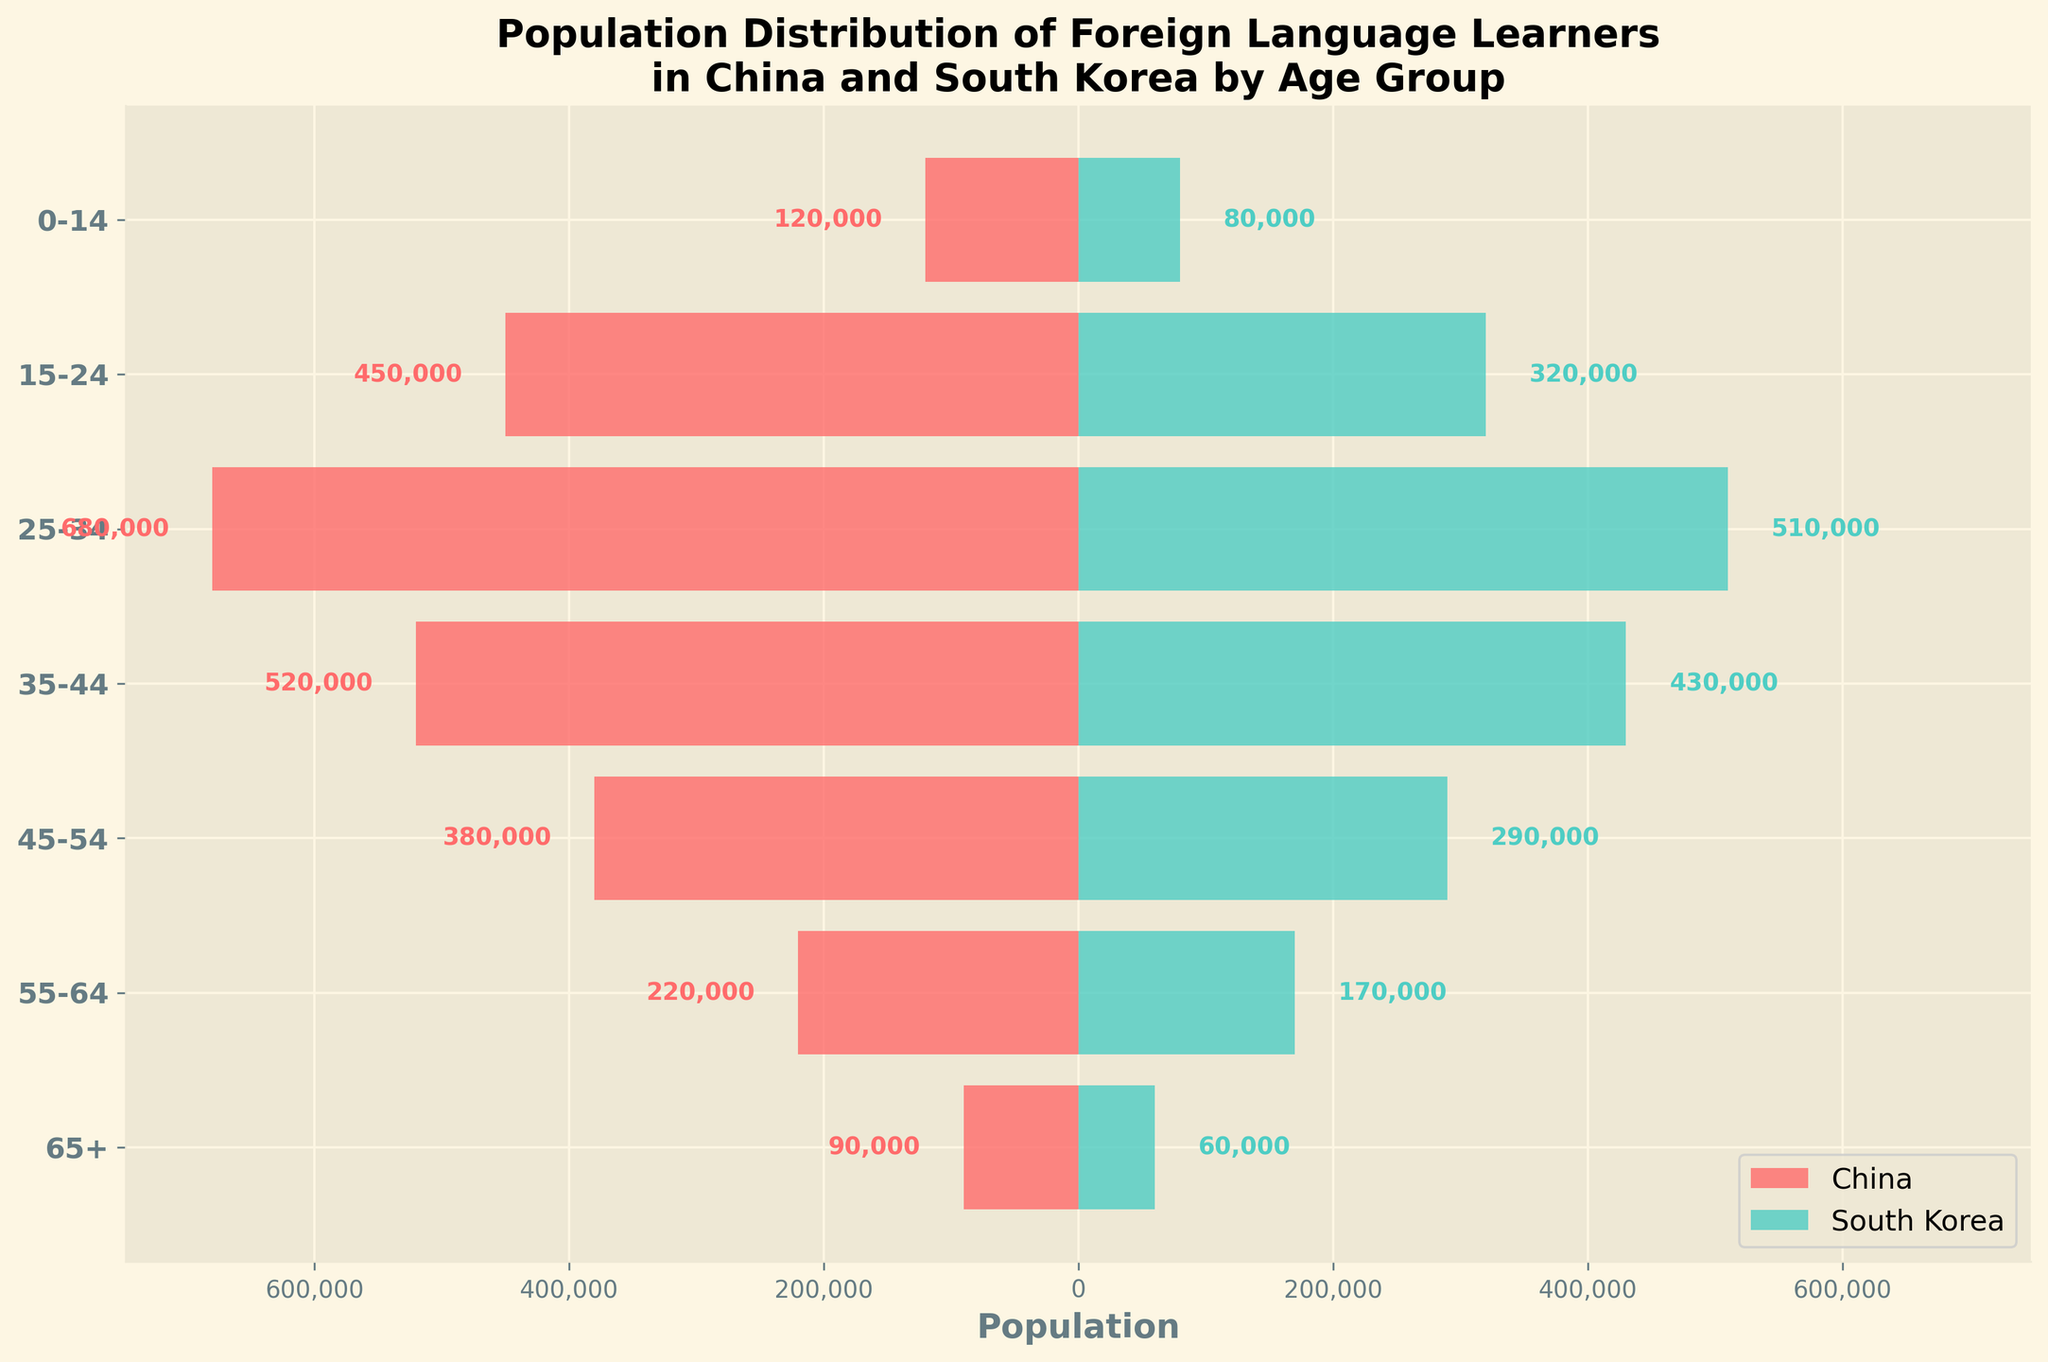Which country has a higher number of foreign language learners in the 25-34 age group? Compare the bars for China and South Korea corresponding to the 25-34 age group. China has 680,000 learners, while South Korea has 510,000.
Answer: China What is the total number of foreign language learners aged 0-14 in both countries? Sum the values for China and South Korea in the 0-14 age group. China: 120,000, South Korea: 80,000. So, 120,000 + 80,000 = 200,000.
Answer: 200,000 Which age group has the highest number of foreign language learners in China? Identify the longest bar for China. The age group 25-34 has the highest number with 680,000 learners.
Answer: 25-34 What is the difference in the number of foreign language learners in the 45-54 age group between China and South Korea? Find the values for China and South Korea in the 45-54 age group and subtract: 380,000 (China) - 290,000 (South Korea) = 90,000.
Answer: 90,000 How does the number of foreign language learners aged 55-64 in South Korea compare to those aged 65+ in China? Compare the bar lengths for the 55-64 age group in South Korea (170,000) and the 65+ age group in China (90,000). 170,000 (South Korea) is greater than 90,000 (China).
Answer: Greater What is the average number of foreign language learners across all age groups in China? Add the numbers for all age groups in China and divide by the number of age groups. (120,000 + 450,000 + 680,000 + 520,000 + 380,000 + 220,000 + 90,000) / 7 = 350,000.
Answer: 350,000 Is there any age group where the number of foreign language learners is equal in China and South Korea? Visually compare the bars for both countries in each age group. All bars are of different lengths in every age group, indicating no equal numbers.
Answer: No Which country has a higher number of foreign language learners overall? Sum the values for all age groups in each country and compare. China: (120,000 + 450,000 + 680,000 + 520,000 + 380,000 + 220,000 + 90,000) = 2,460,000, South Korea: (80,000 + 320,000 + 510,000 + 430,000 + 290,000 + 170,000 + 60,000) = 1,860,000. China has more.
Answer: China In which age group is the difference in the number of foreign language learners between China and South Korea the smallest? Calculate the differences for each age group and find the smallest: (120,000-80,000)=40,000, (450,000-320,000)=130,000, (680,000-510,000)=170,000, (520,000-430,000)=90,000, (380,000-290,000)=90,000, (220,000-170,000)=50,000, (90,000-60,000)=30,000. The smallest difference is 30,000 for the 65+ age group.
Answer: 65+ 